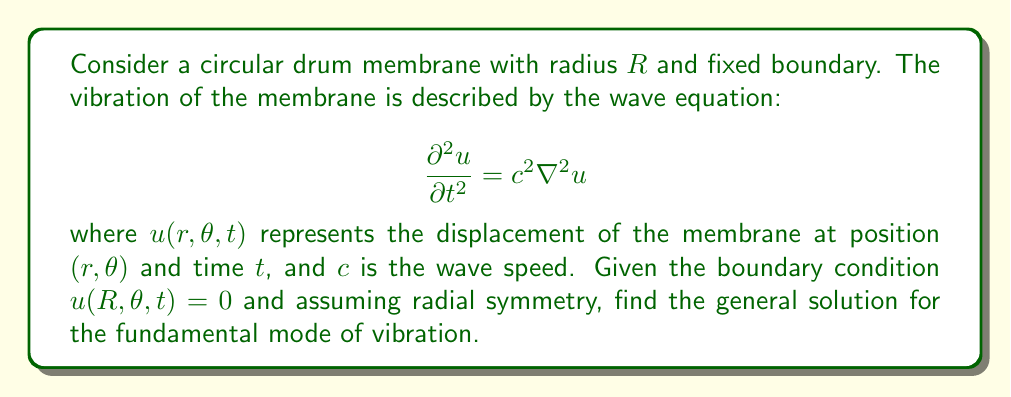Provide a solution to this math problem. Let's approach this step-by-step:

1) Given radial symmetry, we can simplify the problem to depend only on $r$ and $t$. The wave equation in polar coordinates with radial symmetry becomes:

   $$ \frac{\partial^2 u}{\partial t^2} = c^2 \left(\frac{\partial^2 u}{\partial r^2} + \frac{1}{r}\frac{\partial u}{\partial r}\right) $$

2) We can use separation of variables. Let $u(r,t) = R(r)T(t)$. Substituting this into the wave equation:

   $$ R(r)T''(t) = c^2\left(R''(r)T(t) + \frac{1}{r}R'(r)T(t)\right) $$

3) Dividing both sides by $c^2R(r)T(t)$:

   $$ \frac{T''(t)}{c^2T(t)} = \frac{R''(r)}{R(r)} + \frac{1}{r}\frac{R'(r)}{R(r)} $$

4) Since the left side depends only on $t$ and the right side only on $r$, both must equal a constant. Let's call this constant $-k^2$. This gives us two equations:

   $$ T''(t) + k^2c^2T(t) = 0 $$
   $$ r^2R''(r) + rR'(r) + k^2r^2R(r) = 0 $$

5) The second equation is Bessel's equation of order 0. Its general solution is:

   $$ R(r) = AJ_0(kr) + BY_0(kr) $$

   where $J_0$ and $Y_0$ are Bessel functions of the first and second kind, respectively.

6) However, $Y_0$ is singular at $r=0$, so we must have $B=0$ for a physical solution. Thus:

   $$ R(r) = AJ_0(kr) $$

7) The boundary condition $u(R,\theta,t) = 0$ implies $R(R) = 0$, or:

   $$ J_0(kR) = 0 $$

8) The smallest positive solution to this equation gives the fundamental mode. It occurs at $kR \approx 2.4048$.

9) The time-dependent part has the solution:

   $$ T(t) = C\cos(kct) + D\sin(kct) $$

10) Therefore, the general solution for the fundamental mode is:

    $$ u(r,t) = AJ_0(kr)(C\cos(kct) + D\sin(kct)) $$

    where $k \approx 2.4048/R$.
Answer: $u(r,t) = AJ_0(kr)(C\cos(kct) + D\sin(kct))$, $k \approx 2.4048/R$ 